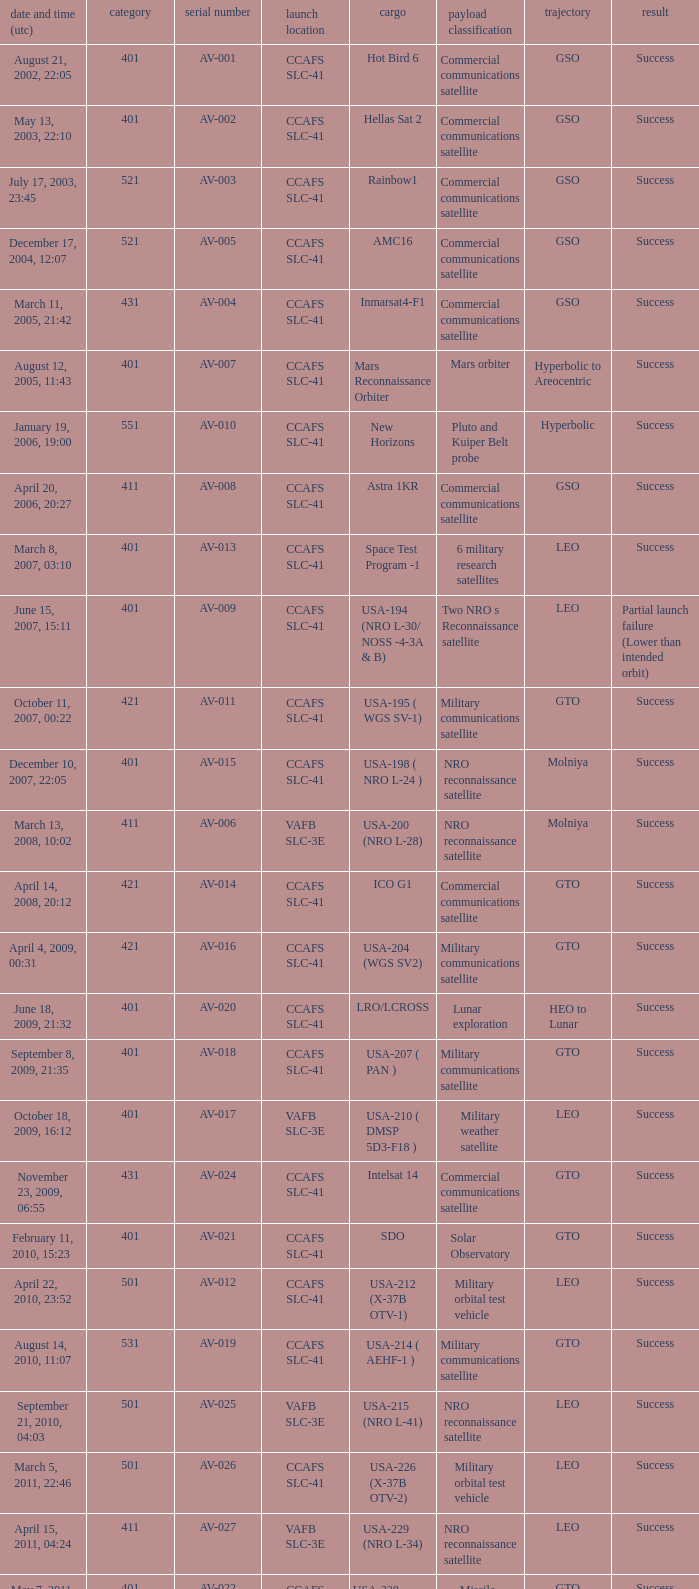For the payload of Van Allen Belts Exploration what's the serial number? AV-032. 